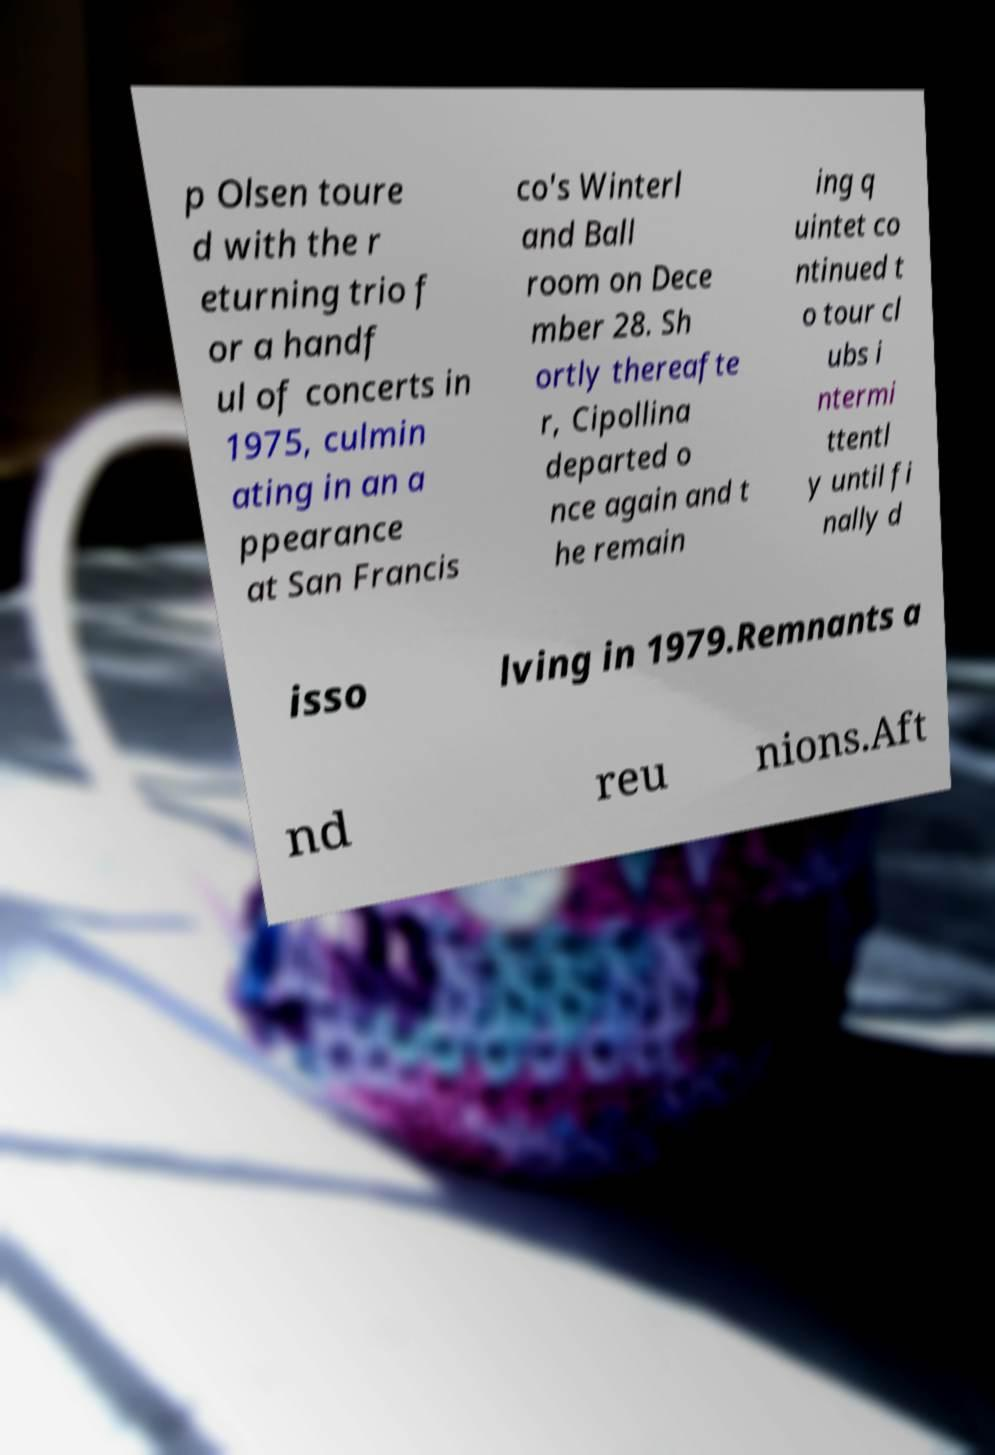Please identify and transcribe the text found in this image. p Olsen toure d with the r eturning trio f or a handf ul of concerts in 1975, culmin ating in an a ppearance at San Francis co's Winterl and Ball room on Dece mber 28. Sh ortly thereafte r, Cipollina departed o nce again and t he remain ing q uintet co ntinued t o tour cl ubs i ntermi ttentl y until fi nally d isso lving in 1979.Remnants a nd reu nions.Aft 